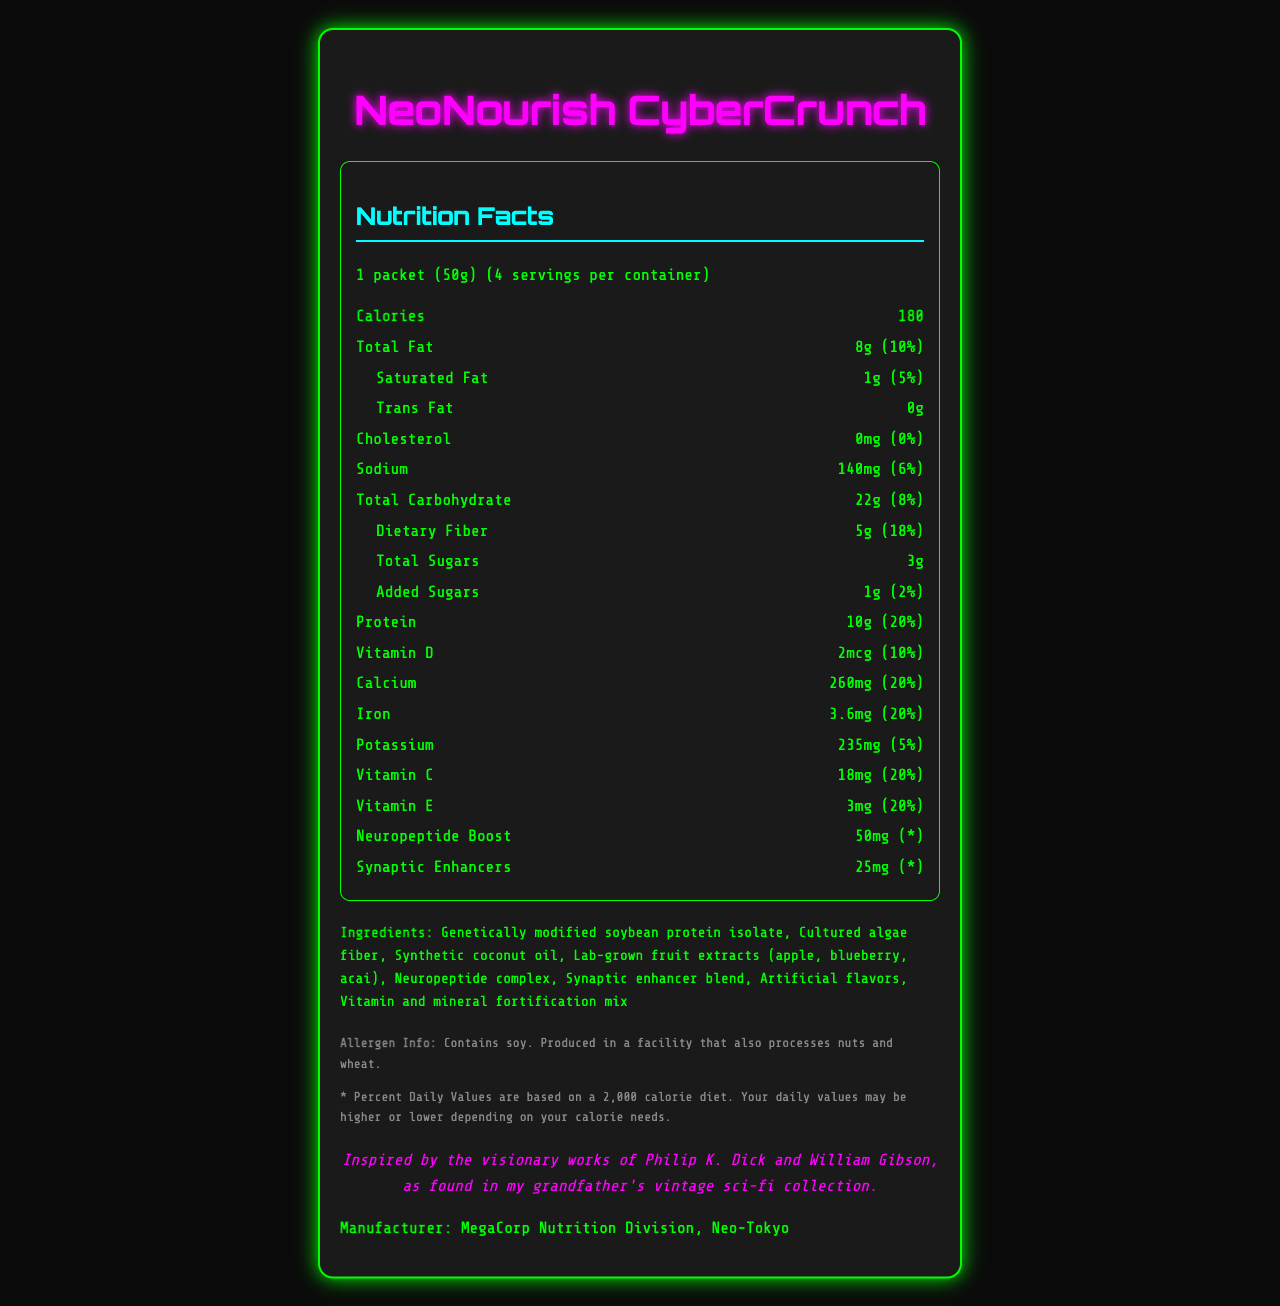how many servings are there per container? The document states there are 4 servings per container.
Answer: 4 What is the serving size for the NeoNourish CyberCrunch? The serving size is explicitly mentioned as "1 packet (50g)".
Answer: 1 packet (50g) How many calories does one serving contain? The calories per serving are listed as 180.
Answer: 180 What are the main ingredients of NeoNourish CyberCrunch? The ingredients are listed in the 'ingredients' section of the document.
Answer: Genetically modified soybean protein isolate, Cultured algae fiber, Synthetic coconut oil, Lab-grown fruit extracts (apple, blueberry, acai), Neuropeptide complex, Synaptic enhancer blend, Artificial flavors, Vitamin and mineral fortification mix How much protein does one serving of this snack provide? The snack provides 10g of protein per serving.
Answer: 10g What is the percentage daily value for dietary fiber per serving? The percentage daily value for dietary fiber is given as 18%.
Answer: 18% Which of the following vitamins has the highest percentage daily value per serving in NeoNourish CyberCrunch? A. Vitamin D B. Calcium C. Iron D. Vitamin C The percentage daily value is 20% for Calcium, Iron, Vitamin C, and Vitamin E, but since Vitamin D is only 10%, Calcium ties for the highest but is noted first in order.
Answer: B. Calcium How much NeuroPeptide Boost does the NeoNourish CyberCrunch contain? A. 15mg B. 25mg C. 35mg D. 50mg The amount of NeuroPeptide Boost is listed as 50mg.
Answer: D. 50mg Does NeoNourish CyberCrunch contain any cholesterol? The document states there is 0mg cholesterol, which means there is no cholesterol present.
Answer: No Summarize the main nutritional benefits of NeoNourish CyberCrunch in one sentence. The product provides impressive amounts of protein, dietary fiber, and essential vitamins, while also offering neuropeptide and synaptic enhancer ingredients for cognitive benefits.
Answer: NeoNourish CyberCrunch is a genetically modified superfood snack high in protein, fiber, and essential vitamins, while also containing unique neuropeptides and synaptic enhancers for cognitive support. What inspired the creation of NeoNourish CyberCrunch? The document mentions an inspiration note referencing works of Philip K. Dick and William Gibson, but it does not detail how these works specifically inspired the creation of the snack.
Answer: Not enough information 